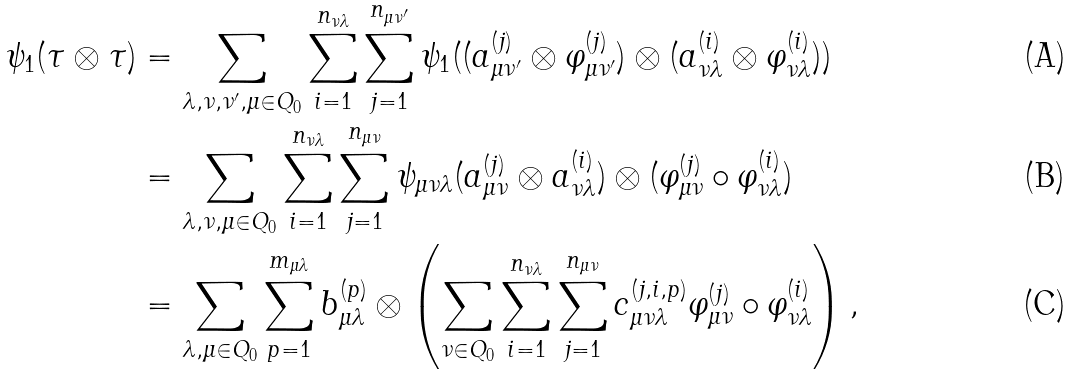<formula> <loc_0><loc_0><loc_500><loc_500>\psi _ { 1 } ( \tau \otimes \tau ) & = \sum _ { \lambda , \nu , \nu ^ { \prime } , \mu \in Q _ { 0 } } \sum _ { i = 1 } ^ { n _ { \nu \lambda } } \sum _ { j = 1 } ^ { n _ { \mu \nu ^ { \prime } } } \psi _ { 1 } ( ( a ^ { ( j ) } _ { \mu \nu ^ { \prime } } \otimes \varphi ^ { ( j ) } _ { \mu \nu ^ { \prime } } ) \otimes ( a ^ { ( i ) } _ { \nu \lambda } \otimes \varphi ^ { ( i ) } _ { \nu \lambda } ) ) \\ & = \sum _ { \lambda , \nu , \mu \in Q _ { 0 } } \sum _ { i = 1 } ^ { n _ { \nu \lambda } } \sum _ { j = 1 } ^ { n _ { \mu \nu } } \psi _ { \mu \nu \lambda } ( a ^ { ( j ) } _ { \mu \nu } \otimes a ^ { ( i ) } _ { \nu \lambda } ) \otimes ( \varphi ^ { ( j ) } _ { \mu \nu } \circ \varphi ^ { ( i ) } _ { \nu \lambda } ) \\ & = \sum _ { \lambda , \mu \in Q _ { 0 } } \sum _ { p = 1 } ^ { m _ { \mu \lambda } } b ^ { ( p ) } _ { \mu \lambda } \otimes \left ( \sum _ { \nu \in Q _ { 0 } } \sum _ { i = 1 } ^ { n _ { \nu \lambda } } \sum _ { j = 1 } ^ { n _ { \mu \nu } } c ^ { ( j , i , p ) } _ { \mu \nu \lambda } \varphi ^ { ( j ) } _ { \mu \nu } \circ \varphi ^ { ( i ) } _ { \nu \lambda } \right ) ,</formula> 